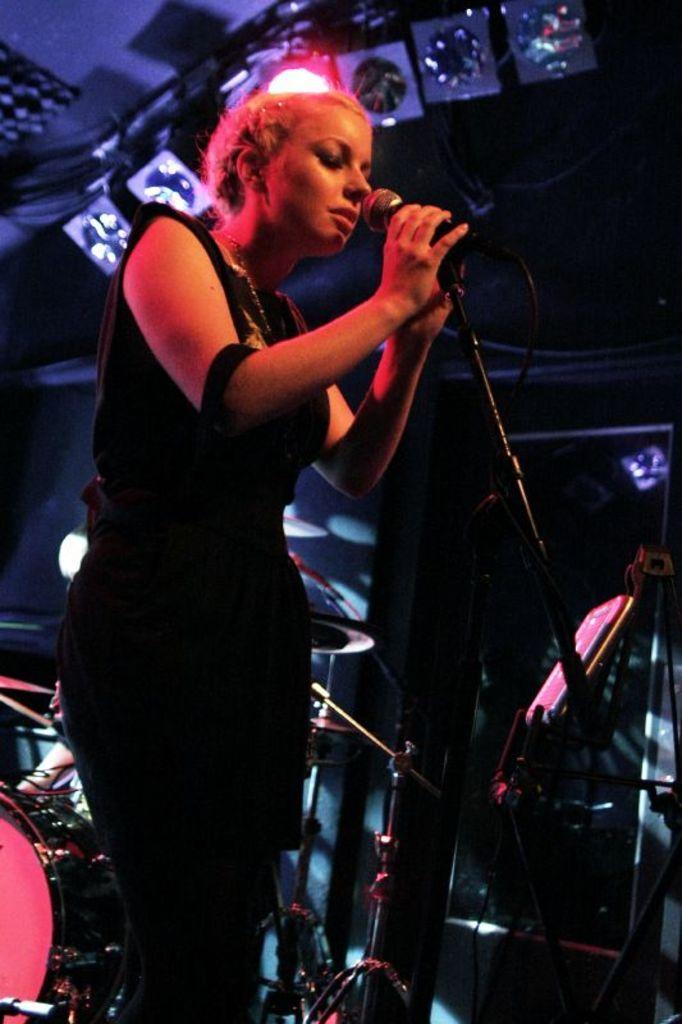In one or two sentences, can you explain what this image depicts? In this image I can see a woman standing in front of the mike and I can see some musical instruments kept in the middle. 